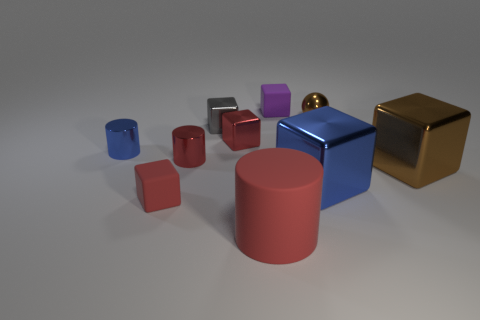Can you tell me what the round object in the image is made of? The round object appears to have a matte surface, suggesting it could be made of a material like plastic or painted metal, characterized by its uniform, non-reflective finish. 